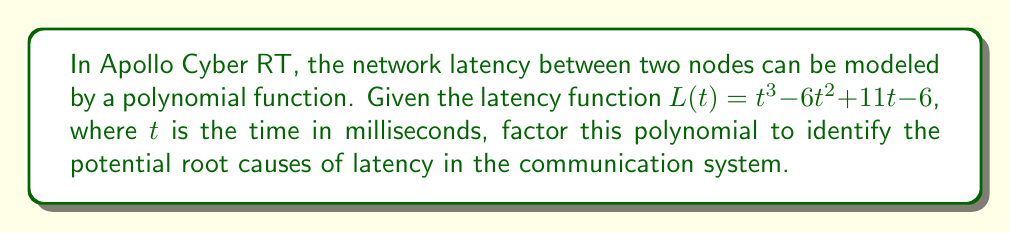Show me your answer to this math problem. To factor the polynomial $L(t) = t^3 - 6t^2 + 11t - 6$, we'll follow these steps:

1) First, let's check if there's a common factor. There isn't, so we proceed.

2) This is a cubic polynomial. Let's try to guess one root. We can use the rational root theorem, which states that if a polynomial equation has integer coefficients, then any rational solution, when reduced to lowest terms, will have a numerator that divides the constant term and a denominator that divides the leading coefficient.

   Possible factors of 6 are: ±1, ±2, ±3, ±6

3) Testing these values, we find that $L(1) = 1 - 6 + 11 - 6 = 0$, so $(t-1)$ is a factor.

4) We can now use polynomial long division to divide $L(t)$ by $(t-1)$:

   $t^3 - 6t^2 + 11t - 6 = (t-1)(t^2 - 5t + 6)$

5) Now we need to factor the quadratic $t^2 - 5t + 6$. We can do this by finding two numbers that multiply to give 6 and add to give -5. These numbers are -2 and -3.

6) Therefore, $t^2 - 5t + 6 = (t-2)(t-3)$

7) Combining all factors, we get:

   $L(t) = (t-1)(t-2)(t-3)$

In the context of network latency, each factor $(t-1)$, $(t-2)$, and $(t-3)$ could represent a distinct source of delay in the communication system, occurring at 1, 2, and 3 milliseconds respectively.
Answer: $L(t) = (t-1)(t-2)(t-3)$ 